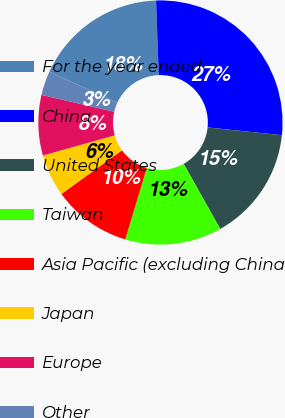Convert chart to OTSL. <chart><loc_0><loc_0><loc_500><loc_500><pie_chart><fcel>For the year ended<fcel>China<fcel>United States<fcel>Taiwan<fcel>Asia Pacific (excluding China<fcel>Japan<fcel>Europe<fcel>Other<nl><fcel>17.61%<fcel>27.22%<fcel>15.2%<fcel>12.8%<fcel>10.4%<fcel>5.59%<fcel>7.99%<fcel>3.19%<nl></chart> 